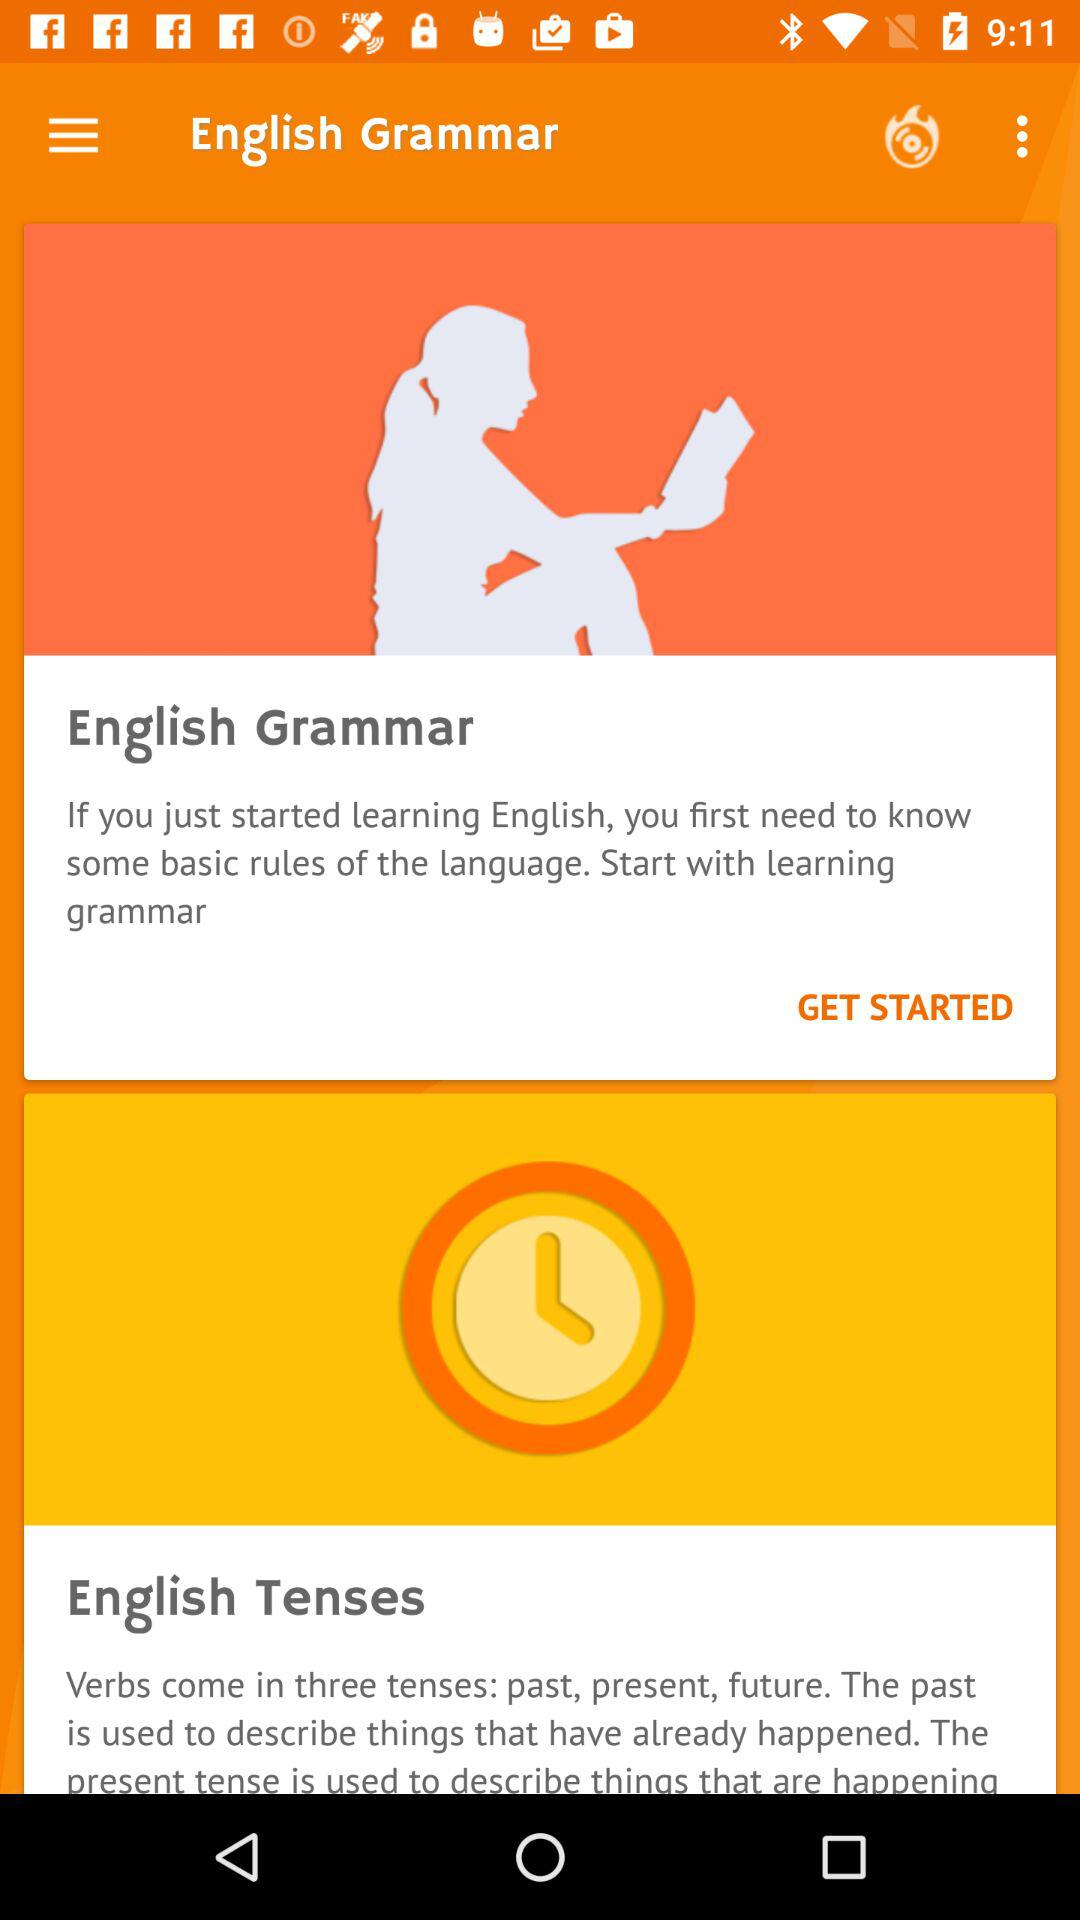What is the name of the application? The name of the application is "English Grammar". 